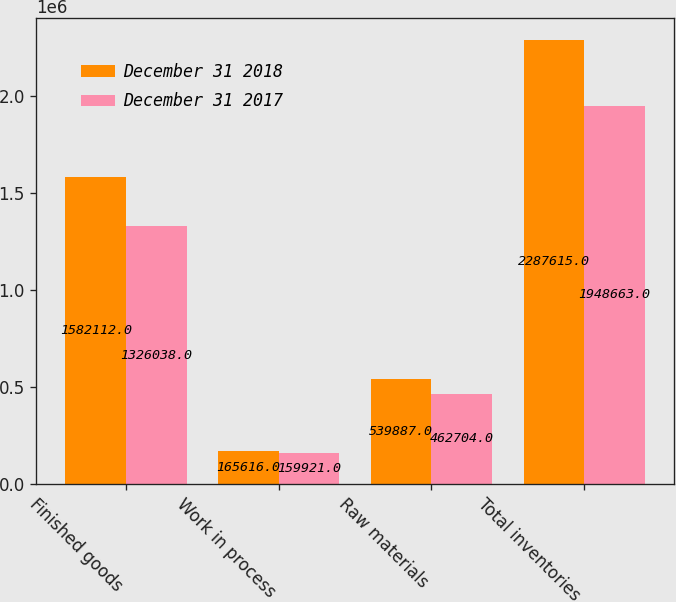Convert chart to OTSL. <chart><loc_0><loc_0><loc_500><loc_500><stacked_bar_chart><ecel><fcel>Finished goods<fcel>Work in process<fcel>Raw materials<fcel>Total inventories<nl><fcel>December 31 2018<fcel>1.58211e+06<fcel>165616<fcel>539887<fcel>2.28762e+06<nl><fcel>December 31 2017<fcel>1.32604e+06<fcel>159921<fcel>462704<fcel>1.94866e+06<nl></chart> 